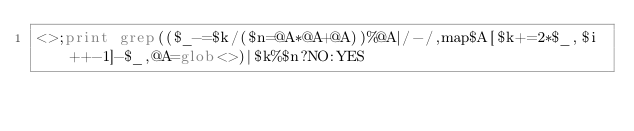Convert code to text. <code><loc_0><loc_0><loc_500><loc_500><_Perl_><>;print grep(($_-=$k/($n=@A*@A+@A))%@A|/-/,map$A[$k+=2*$_,$i++-1]-$_,@A=glob<>)|$k%$n?NO:YES</code> 